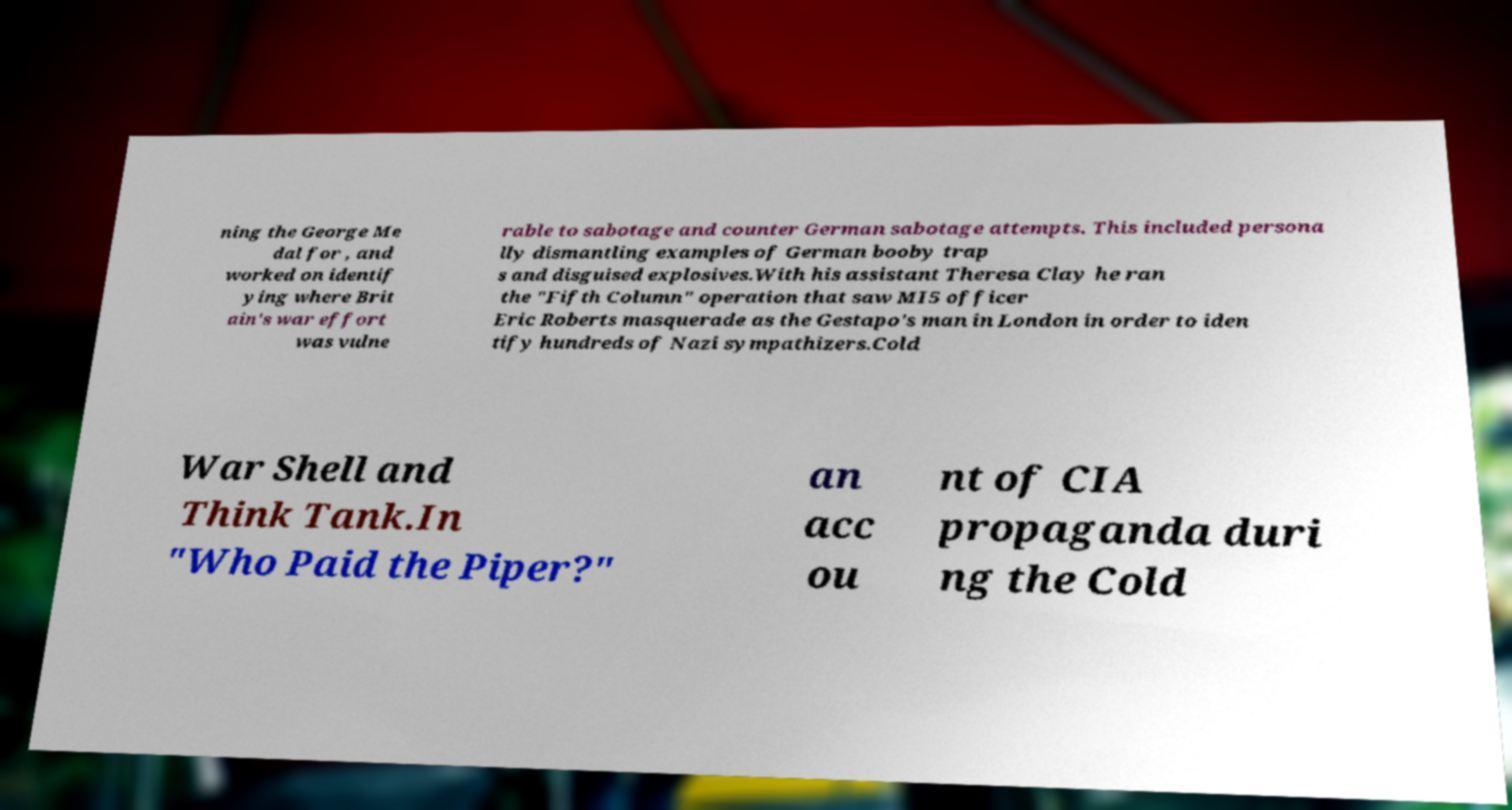What messages or text are displayed in this image? I need them in a readable, typed format. ning the George Me dal for , and worked on identif ying where Brit ain's war effort was vulne rable to sabotage and counter German sabotage attempts. This included persona lly dismantling examples of German booby trap s and disguised explosives.With his assistant Theresa Clay he ran the "Fifth Column" operation that saw MI5 officer Eric Roberts masquerade as the Gestapo's man in London in order to iden tify hundreds of Nazi sympathizers.Cold War Shell and Think Tank.In "Who Paid the Piper?" an acc ou nt of CIA propaganda duri ng the Cold 